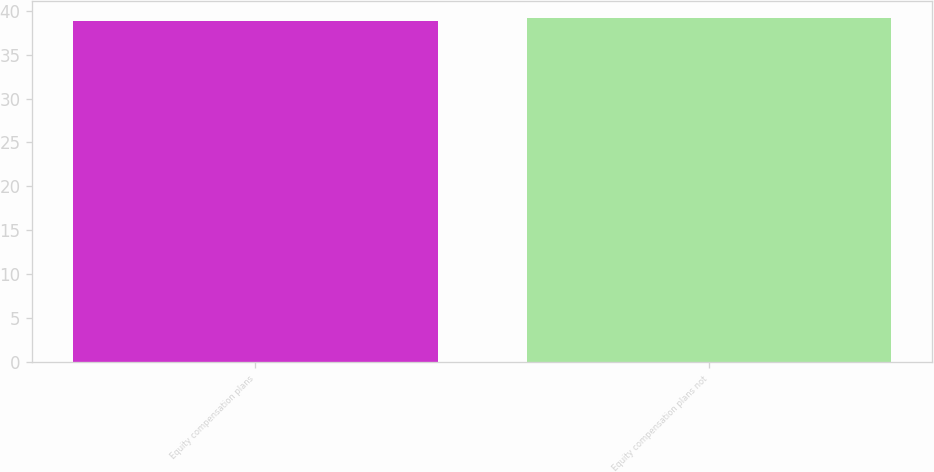Convert chart. <chart><loc_0><loc_0><loc_500><loc_500><bar_chart><fcel>Equity compensation plans<fcel>Equity compensation plans not<nl><fcel>38.82<fcel>39.11<nl></chart> 